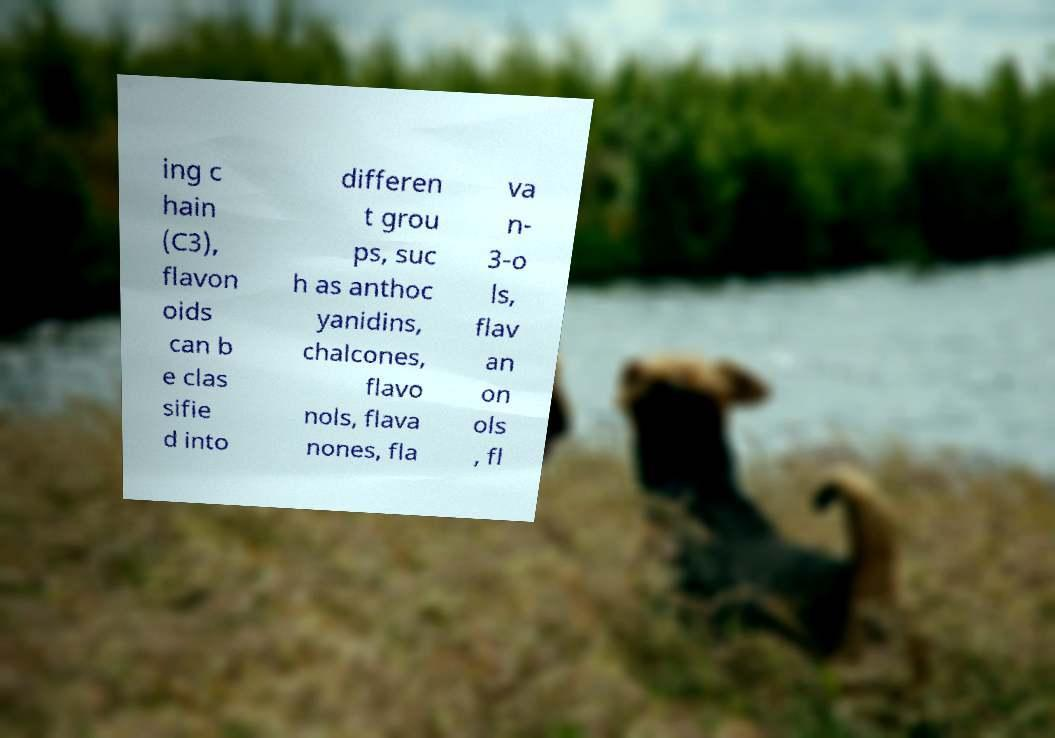Can you accurately transcribe the text from the provided image for me? ing c hain (C3), flavon oids can b e clas sifie d into differen t grou ps, suc h as anthoc yanidins, chalcones, flavo nols, flava nones, fla va n- 3-o ls, flav an on ols , fl 